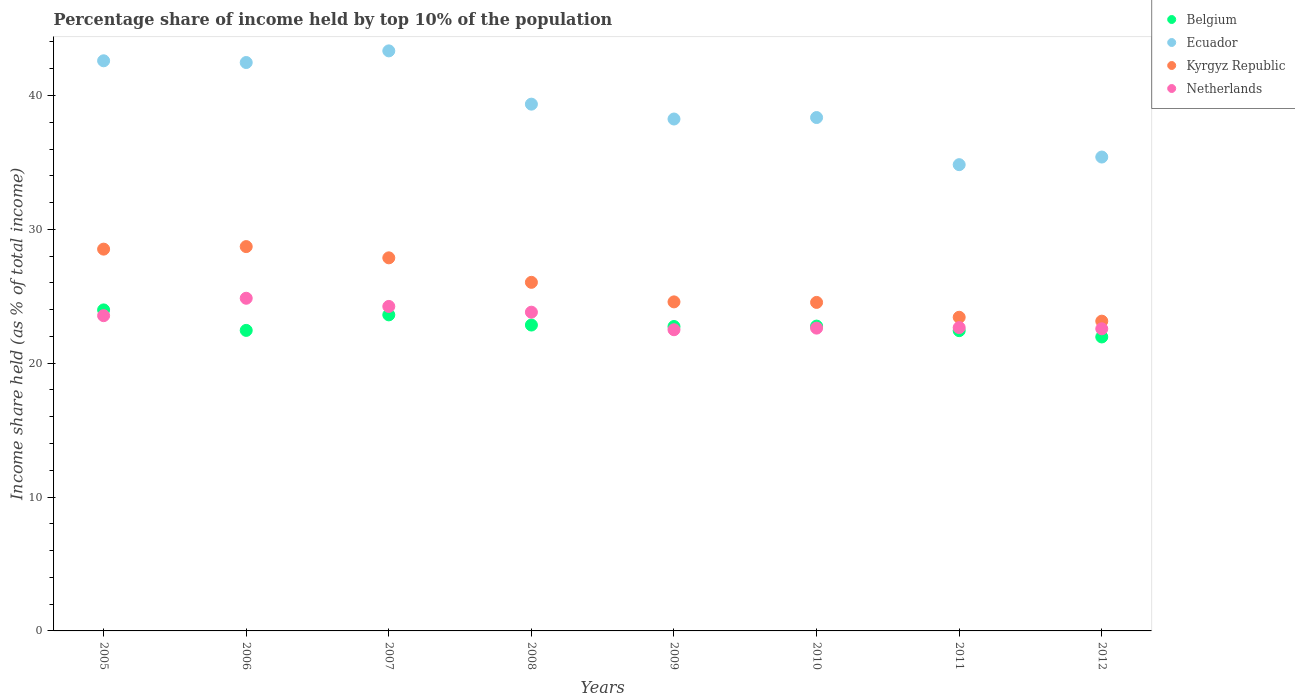Is the number of dotlines equal to the number of legend labels?
Your response must be concise. Yes. What is the percentage share of income held by top 10% of the population in Netherlands in 2006?
Provide a succinct answer. 24.85. Across all years, what is the maximum percentage share of income held by top 10% of the population in Netherlands?
Offer a terse response. 24.85. Across all years, what is the minimum percentage share of income held by top 10% of the population in Ecuador?
Offer a very short reply. 34.83. In which year was the percentage share of income held by top 10% of the population in Ecuador maximum?
Your answer should be very brief. 2007. What is the total percentage share of income held by top 10% of the population in Kyrgyz Republic in the graph?
Provide a short and direct response. 206.83. What is the difference between the percentage share of income held by top 10% of the population in Belgium in 2005 and that in 2008?
Provide a short and direct response. 1.13. What is the difference between the percentage share of income held by top 10% of the population in Belgium in 2005 and the percentage share of income held by top 10% of the population in Kyrgyz Republic in 2009?
Make the answer very short. -0.6. What is the average percentage share of income held by top 10% of the population in Kyrgyz Republic per year?
Offer a very short reply. 25.85. In the year 2009, what is the difference between the percentage share of income held by top 10% of the population in Belgium and percentage share of income held by top 10% of the population in Ecuador?
Offer a very short reply. -15.5. In how many years, is the percentage share of income held by top 10% of the population in Belgium greater than 28 %?
Your answer should be very brief. 0. What is the ratio of the percentage share of income held by top 10% of the population in Ecuador in 2008 to that in 2009?
Your answer should be compact. 1.03. Is the difference between the percentage share of income held by top 10% of the population in Belgium in 2011 and 2012 greater than the difference between the percentage share of income held by top 10% of the population in Ecuador in 2011 and 2012?
Provide a short and direct response. Yes. What is the difference between the highest and the second highest percentage share of income held by top 10% of the population in Netherlands?
Provide a succinct answer. 0.61. What is the difference between the highest and the lowest percentage share of income held by top 10% of the population in Kyrgyz Republic?
Offer a terse response. 5.57. Is it the case that in every year, the sum of the percentage share of income held by top 10% of the population in Netherlands and percentage share of income held by top 10% of the population in Kyrgyz Republic  is greater than the percentage share of income held by top 10% of the population in Belgium?
Your answer should be compact. Yes. Does the percentage share of income held by top 10% of the population in Netherlands monotonically increase over the years?
Your answer should be compact. No. How many dotlines are there?
Keep it short and to the point. 4. Are the values on the major ticks of Y-axis written in scientific E-notation?
Keep it short and to the point. No. How many legend labels are there?
Provide a short and direct response. 4. How are the legend labels stacked?
Your answer should be compact. Vertical. What is the title of the graph?
Offer a very short reply. Percentage share of income held by top 10% of the population. What is the label or title of the X-axis?
Your answer should be very brief. Years. What is the label or title of the Y-axis?
Provide a succinct answer. Income share held (as % of total income). What is the Income share held (as % of total income) in Belgium in 2005?
Ensure brevity in your answer.  23.98. What is the Income share held (as % of total income) of Ecuador in 2005?
Offer a very short reply. 42.59. What is the Income share held (as % of total income) in Kyrgyz Republic in 2005?
Make the answer very short. 28.52. What is the Income share held (as % of total income) in Netherlands in 2005?
Ensure brevity in your answer.  23.55. What is the Income share held (as % of total income) in Belgium in 2006?
Offer a terse response. 22.45. What is the Income share held (as % of total income) in Ecuador in 2006?
Offer a terse response. 42.46. What is the Income share held (as % of total income) of Kyrgyz Republic in 2006?
Make the answer very short. 28.71. What is the Income share held (as % of total income) of Netherlands in 2006?
Keep it short and to the point. 24.85. What is the Income share held (as % of total income) of Belgium in 2007?
Your response must be concise. 23.61. What is the Income share held (as % of total income) of Ecuador in 2007?
Ensure brevity in your answer.  43.33. What is the Income share held (as % of total income) of Kyrgyz Republic in 2007?
Your answer should be very brief. 27.87. What is the Income share held (as % of total income) in Netherlands in 2007?
Ensure brevity in your answer.  24.24. What is the Income share held (as % of total income) in Belgium in 2008?
Make the answer very short. 22.85. What is the Income share held (as % of total income) in Ecuador in 2008?
Provide a short and direct response. 39.35. What is the Income share held (as % of total income) of Kyrgyz Republic in 2008?
Give a very brief answer. 26.04. What is the Income share held (as % of total income) in Netherlands in 2008?
Your answer should be very brief. 23.81. What is the Income share held (as % of total income) of Belgium in 2009?
Your answer should be very brief. 22.74. What is the Income share held (as % of total income) in Ecuador in 2009?
Make the answer very short. 38.24. What is the Income share held (as % of total income) in Kyrgyz Republic in 2009?
Offer a very short reply. 24.58. What is the Income share held (as % of total income) of Netherlands in 2009?
Keep it short and to the point. 22.5. What is the Income share held (as % of total income) in Belgium in 2010?
Make the answer very short. 22.77. What is the Income share held (as % of total income) in Ecuador in 2010?
Offer a terse response. 38.35. What is the Income share held (as % of total income) in Kyrgyz Republic in 2010?
Offer a terse response. 24.54. What is the Income share held (as % of total income) of Netherlands in 2010?
Keep it short and to the point. 22.62. What is the Income share held (as % of total income) of Belgium in 2011?
Your response must be concise. 22.43. What is the Income share held (as % of total income) in Ecuador in 2011?
Provide a succinct answer. 34.83. What is the Income share held (as % of total income) in Kyrgyz Republic in 2011?
Give a very brief answer. 23.43. What is the Income share held (as % of total income) of Netherlands in 2011?
Make the answer very short. 22.66. What is the Income share held (as % of total income) of Belgium in 2012?
Provide a short and direct response. 21.96. What is the Income share held (as % of total income) of Ecuador in 2012?
Offer a very short reply. 35.4. What is the Income share held (as % of total income) of Kyrgyz Republic in 2012?
Provide a short and direct response. 23.14. What is the Income share held (as % of total income) in Netherlands in 2012?
Provide a succinct answer. 22.57. Across all years, what is the maximum Income share held (as % of total income) in Belgium?
Offer a terse response. 23.98. Across all years, what is the maximum Income share held (as % of total income) of Ecuador?
Your answer should be very brief. 43.33. Across all years, what is the maximum Income share held (as % of total income) of Kyrgyz Republic?
Give a very brief answer. 28.71. Across all years, what is the maximum Income share held (as % of total income) of Netherlands?
Offer a terse response. 24.85. Across all years, what is the minimum Income share held (as % of total income) of Belgium?
Your answer should be compact. 21.96. Across all years, what is the minimum Income share held (as % of total income) in Ecuador?
Give a very brief answer. 34.83. Across all years, what is the minimum Income share held (as % of total income) in Kyrgyz Republic?
Give a very brief answer. 23.14. Across all years, what is the minimum Income share held (as % of total income) of Netherlands?
Offer a terse response. 22.5. What is the total Income share held (as % of total income) in Belgium in the graph?
Give a very brief answer. 182.79. What is the total Income share held (as % of total income) in Ecuador in the graph?
Provide a succinct answer. 314.55. What is the total Income share held (as % of total income) of Kyrgyz Republic in the graph?
Your answer should be very brief. 206.83. What is the total Income share held (as % of total income) of Netherlands in the graph?
Provide a succinct answer. 186.8. What is the difference between the Income share held (as % of total income) of Belgium in 2005 and that in 2006?
Give a very brief answer. 1.53. What is the difference between the Income share held (as % of total income) of Ecuador in 2005 and that in 2006?
Keep it short and to the point. 0.13. What is the difference between the Income share held (as % of total income) of Kyrgyz Republic in 2005 and that in 2006?
Ensure brevity in your answer.  -0.19. What is the difference between the Income share held (as % of total income) of Netherlands in 2005 and that in 2006?
Provide a short and direct response. -1.3. What is the difference between the Income share held (as % of total income) in Belgium in 2005 and that in 2007?
Provide a short and direct response. 0.37. What is the difference between the Income share held (as % of total income) in Ecuador in 2005 and that in 2007?
Provide a succinct answer. -0.74. What is the difference between the Income share held (as % of total income) of Kyrgyz Republic in 2005 and that in 2007?
Keep it short and to the point. 0.65. What is the difference between the Income share held (as % of total income) of Netherlands in 2005 and that in 2007?
Offer a very short reply. -0.69. What is the difference between the Income share held (as % of total income) of Belgium in 2005 and that in 2008?
Provide a succinct answer. 1.13. What is the difference between the Income share held (as % of total income) in Ecuador in 2005 and that in 2008?
Offer a very short reply. 3.24. What is the difference between the Income share held (as % of total income) in Kyrgyz Republic in 2005 and that in 2008?
Provide a short and direct response. 2.48. What is the difference between the Income share held (as % of total income) of Netherlands in 2005 and that in 2008?
Provide a succinct answer. -0.26. What is the difference between the Income share held (as % of total income) in Belgium in 2005 and that in 2009?
Your answer should be very brief. 1.24. What is the difference between the Income share held (as % of total income) in Ecuador in 2005 and that in 2009?
Provide a short and direct response. 4.35. What is the difference between the Income share held (as % of total income) in Kyrgyz Republic in 2005 and that in 2009?
Your answer should be compact. 3.94. What is the difference between the Income share held (as % of total income) of Belgium in 2005 and that in 2010?
Offer a very short reply. 1.21. What is the difference between the Income share held (as % of total income) in Ecuador in 2005 and that in 2010?
Provide a short and direct response. 4.24. What is the difference between the Income share held (as % of total income) of Kyrgyz Republic in 2005 and that in 2010?
Your answer should be very brief. 3.98. What is the difference between the Income share held (as % of total income) in Netherlands in 2005 and that in 2010?
Offer a terse response. 0.93. What is the difference between the Income share held (as % of total income) of Belgium in 2005 and that in 2011?
Offer a very short reply. 1.55. What is the difference between the Income share held (as % of total income) in Ecuador in 2005 and that in 2011?
Keep it short and to the point. 7.76. What is the difference between the Income share held (as % of total income) in Kyrgyz Republic in 2005 and that in 2011?
Your response must be concise. 5.09. What is the difference between the Income share held (as % of total income) of Netherlands in 2005 and that in 2011?
Give a very brief answer. 0.89. What is the difference between the Income share held (as % of total income) of Belgium in 2005 and that in 2012?
Make the answer very short. 2.02. What is the difference between the Income share held (as % of total income) in Ecuador in 2005 and that in 2012?
Your answer should be compact. 7.19. What is the difference between the Income share held (as % of total income) of Kyrgyz Republic in 2005 and that in 2012?
Provide a succinct answer. 5.38. What is the difference between the Income share held (as % of total income) of Belgium in 2006 and that in 2007?
Offer a terse response. -1.16. What is the difference between the Income share held (as % of total income) of Ecuador in 2006 and that in 2007?
Make the answer very short. -0.87. What is the difference between the Income share held (as % of total income) of Kyrgyz Republic in 2006 and that in 2007?
Give a very brief answer. 0.84. What is the difference between the Income share held (as % of total income) in Netherlands in 2006 and that in 2007?
Keep it short and to the point. 0.61. What is the difference between the Income share held (as % of total income) of Belgium in 2006 and that in 2008?
Give a very brief answer. -0.4. What is the difference between the Income share held (as % of total income) in Ecuador in 2006 and that in 2008?
Keep it short and to the point. 3.11. What is the difference between the Income share held (as % of total income) in Kyrgyz Republic in 2006 and that in 2008?
Give a very brief answer. 2.67. What is the difference between the Income share held (as % of total income) in Belgium in 2006 and that in 2009?
Offer a very short reply. -0.29. What is the difference between the Income share held (as % of total income) in Ecuador in 2006 and that in 2009?
Provide a succinct answer. 4.22. What is the difference between the Income share held (as % of total income) of Kyrgyz Republic in 2006 and that in 2009?
Give a very brief answer. 4.13. What is the difference between the Income share held (as % of total income) of Netherlands in 2006 and that in 2009?
Give a very brief answer. 2.35. What is the difference between the Income share held (as % of total income) in Belgium in 2006 and that in 2010?
Ensure brevity in your answer.  -0.32. What is the difference between the Income share held (as % of total income) in Ecuador in 2006 and that in 2010?
Offer a terse response. 4.11. What is the difference between the Income share held (as % of total income) of Kyrgyz Republic in 2006 and that in 2010?
Provide a short and direct response. 4.17. What is the difference between the Income share held (as % of total income) of Netherlands in 2006 and that in 2010?
Provide a short and direct response. 2.23. What is the difference between the Income share held (as % of total income) in Belgium in 2006 and that in 2011?
Your answer should be very brief. 0.02. What is the difference between the Income share held (as % of total income) in Ecuador in 2006 and that in 2011?
Your answer should be compact. 7.63. What is the difference between the Income share held (as % of total income) in Kyrgyz Republic in 2006 and that in 2011?
Offer a very short reply. 5.28. What is the difference between the Income share held (as % of total income) in Netherlands in 2006 and that in 2011?
Give a very brief answer. 2.19. What is the difference between the Income share held (as % of total income) in Belgium in 2006 and that in 2012?
Offer a terse response. 0.49. What is the difference between the Income share held (as % of total income) of Ecuador in 2006 and that in 2012?
Your response must be concise. 7.06. What is the difference between the Income share held (as % of total income) in Kyrgyz Republic in 2006 and that in 2012?
Offer a terse response. 5.57. What is the difference between the Income share held (as % of total income) in Netherlands in 2006 and that in 2012?
Keep it short and to the point. 2.28. What is the difference between the Income share held (as % of total income) in Belgium in 2007 and that in 2008?
Keep it short and to the point. 0.76. What is the difference between the Income share held (as % of total income) of Ecuador in 2007 and that in 2008?
Your answer should be very brief. 3.98. What is the difference between the Income share held (as % of total income) of Kyrgyz Republic in 2007 and that in 2008?
Keep it short and to the point. 1.83. What is the difference between the Income share held (as % of total income) in Netherlands in 2007 and that in 2008?
Offer a very short reply. 0.43. What is the difference between the Income share held (as % of total income) of Belgium in 2007 and that in 2009?
Provide a short and direct response. 0.87. What is the difference between the Income share held (as % of total income) of Ecuador in 2007 and that in 2009?
Offer a terse response. 5.09. What is the difference between the Income share held (as % of total income) of Kyrgyz Republic in 2007 and that in 2009?
Give a very brief answer. 3.29. What is the difference between the Income share held (as % of total income) of Netherlands in 2007 and that in 2009?
Offer a terse response. 1.74. What is the difference between the Income share held (as % of total income) of Belgium in 2007 and that in 2010?
Make the answer very short. 0.84. What is the difference between the Income share held (as % of total income) of Ecuador in 2007 and that in 2010?
Offer a terse response. 4.98. What is the difference between the Income share held (as % of total income) of Kyrgyz Republic in 2007 and that in 2010?
Offer a very short reply. 3.33. What is the difference between the Income share held (as % of total income) in Netherlands in 2007 and that in 2010?
Offer a very short reply. 1.62. What is the difference between the Income share held (as % of total income) of Belgium in 2007 and that in 2011?
Ensure brevity in your answer.  1.18. What is the difference between the Income share held (as % of total income) of Kyrgyz Republic in 2007 and that in 2011?
Your answer should be compact. 4.44. What is the difference between the Income share held (as % of total income) in Netherlands in 2007 and that in 2011?
Keep it short and to the point. 1.58. What is the difference between the Income share held (as % of total income) in Belgium in 2007 and that in 2012?
Your answer should be compact. 1.65. What is the difference between the Income share held (as % of total income) of Ecuador in 2007 and that in 2012?
Offer a terse response. 7.93. What is the difference between the Income share held (as % of total income) in Kyrgyz Republic in 2007 and that in 2012?
Provide a succinct answer. 4.73. What is the difference between the Income share held (as % of total income) of Netherlands in 2007 and that in 2012?
Your answer should be compact. 1.67. What is the difference between the Income share held (as % of total income) in Belgium in 2008 and that in 2009?
Make the answer very short. 0.11. What is the difference between the Income share held (as % of total income) of Ecuador in 2008 and that in 2009?
Offer a terse response. 1.11. What is the difference between the Income share held (as % of total income) of Kyrgyz Republic in 2008 and that in 2009?
Keep it short and to the point. 1.46. What is the difference between the Income share held (as % of total income) in Netherlands in 2008 and that in 2009?
Ensure brevity in your answer.  1.31. What is the difference between the Income share held (as % of total income) of Belgium in 2008 and that in 2010?
Your response must be concise. 0.08. What is the difference between the Income share held (as % of total income) in Kyrgyz Republic in 2008 and that in 2010?
Offer a very short reply. 1.5. What is the difference between the Income share held (as % of total income) in Netherlands in 2008 and that in 2010?
Offer a very short reply. 1.19. What is the difference between the Income share held (as % of total income) in Belgium in 2008 and that in 2011?
Provide a short and direct response. 0.42. What is the difference between the Income share held (as % of total income) in Ecuador in 2008 and that in 2011?
Your answer should be very brief. 4.52. What is the difference between the Income share held (as % of total income) in Kyrgyz Republic in 2008 and that in 2011?
Offer a very short reply. 2.61. What is the difference between the Income share held (as % of total income) in Netherlands in 2008 and that in 2011?
Provide a short and direct response. 1.15. What is the difference between the Income share held (as % of total income) in Belgium in 2008 and that in 2012?
Your answer should be very brief. 0.89. What is the difference between the Income share held (as % of total income) of Ecuador in 2008 and that in 2012?
Offer a terse response. 3.95. What is the difference between the Income share held (as % of total income) in Netherlands in 2008 and that in 2012?
Provide a short and direct response. 1.24. What is the difference between the Income share held (as % of total income) of Belgium in 2009 and that in 2010?
Your response must be concise. -0.03. What is the difference between the Income share held (as % of total income) in Ecuador in 2009 and that in 2010?
Your answer should be very brief. -0.11. What is the difference between the Income share held (as % of total income) in Kyrgyz Republic in 2009 and that in 2010?
Offer a terse response. 0.04. What is the difference between the Income share held (as % of total income) in Netherlands in 2009 and that in 2010?
Offer a very short reply. -0.12. What is the difference between the Income share held (as % of total income) in Belgium in 2009 and that in 2011?
Your answer should be compact. 0.31. What is the difference between the Income share held (as % of total income) of Ecuador in 2009 and that in 2011?
Keep it short and to the point. 3.41. What is the difference between the Income share held (as % of total income) in Kyrgyz Republic in 2009 and that in 2011?
Keep it short and to the point. 1.15. What is the difference between the Income share held (as % of total income) of Netherlands in 2009 and that in 2011?
Offer a very short reply. -0.16. What is the difference between the Income share held (as % of total income) in Belgium in 2009 and that in 2012?
Provide a succinct answer. 0.78. What is the difference between the Income share held (as % of total income) in Ecuador in 2009 and that in 2012?
Keep it short and to the point. 2.84. What is the difference between the Income share held (as % of total income) of Kyrgyz Republic in 2009 and that in 2012?
Give a very brief answer. 1.44. What is the difference between the Income share held (as % of total income) in Netherlands in 2009 and that in 2012?
Offer a very short reply. -0.07. What is the difference between the Income share held (as % of total income) of Belgium in 2010 and that in 2011?
Provide a short and direct response. 0.34. What is the difference between the Income share held (as % of total income) of Ecuador in 2010 and that in 2011?
Provide a short and direct response. 3.52. What is the difference between the Income share held (as % of total income) of Kyrgyz Republic in 2010 and that in 2011?
Keep it short and to the point. 1.11. What is the difference between the Income share held (as % of total income) in Netherlands in 2010 and that in 2011?
Provide a short and direct response. -0.04. What is the difference between the Income share held (as % of total income) of Belgium in 2010 and that in 2012?
Offer a very short reply. 0.81. What is the difference between the Income share held (as % of total income) in Ecuador in 2010 and that in 2012?
Give a very brief answer. 2.95. What is the difference between the Income share held (as % of total income) in Kyrgyz Republic in 2010 and that in 2012?
Keep it short and to the point. 1.4. What is the difference between the Income share held (as % of total income) in Belgium in 2011 and that in 2012?
Ensure brevity in your answer.  0.47. What is the difference between the Income share held (as % of total income) in Ecuador in 2011 and that in 2012?
Make the answer very short. -0.57. What is the difference between the Income share held (as % of total income) of Kyrgyz Republic in 2011 and that in 2012?
Offer a very short reply. 0.29. What is the difference between the Income share held (as % of total income) of Netherlands in 2011 and that in 2012?
Ensure brevity in your answer.  0.09. What is the difference between the Income share held (as % of total income) in Belgium in 2005 and the Income share held (as % of total income) in Ecuador in 2006?
Ensure brevity in your answer.  -18.48. What is the difference between the Income share held (as % of total income) in Belgium in 2005 and the Income share held (as % of total income) in Kyrgyz Republic in 2006?
Provide a succinct answer. -4.73. What is the difference between the Income share held (as % of total income) of Belgium in 2005 and the Income share held (as % of total income) of Netherlands in 2006?
Provide a short and direct response. -0.87. What is the difference between the Income share held (as % of total income) of Ecuador in 2005 and the Income share held (as % of total income) of Kyrgyz Republic in 2006?
Offer a terse response. 13.88. What is the difference between the Income share held (as % of total income) of Ecuador in 2005 and the Income share held (as % of total income) of Netherlands in 2006?
Make the answer very short. 17.74. What is the difference between the Income share held (as % of total income) of Kyrgyz Republic in 2005 and the Income share held (as % of total income) of Netherlands in 2006?
Ensure brevity in your answer.  3.67. What is the difference between the Income share held (as % of total income) of Belgium in 2005 and the Income share held (as % of total income) of Ecuador in 2007?
Give a very brief answer. -19.35. What is the difference between the Income share held (as % of total income) in Belgium in 2005 and the Income share held (as % of total income) in Kyrgyz Republic in 2007?
Your answer should be compact. -3.89. What is the difference between the Income share held (as % of total income) in Belgium in 2005 and the Income share held (as % of total income) in Netherlands in 2007?
Make the answer very short. -0.26. What is the difference between the Income share held (as % of total income) of Ecuador in 2005 and the Income share held (as % of total income) of Kyrgyz Republic in 2007?
Provide a succinct answer. 14.72. What is the difference between the Income share held (as % of total income) in Ecuador in 2005 and the Income share held (as % of total income) in Netherlands in 2007?
Make the answer very short. 18.35. What is the difference between the Income share held (as % of total income) of Kyrgyz Republic in 2005 and the Income share held (as % of total income) of Netherlands in 2007?
Your answer should be compact. 4.28. What is the difference between the Income share held (as % of total income) of Belgium in 2005 and the Income share held (as % of total income) of Ecuador in 2008?
Offer a terse response. -15.37. What is the difference between the Income share held (as % of total income) in Belgium in 2005 and the Income share held (as % of total income) in Kyrgyz Republic in 2008?
Provide a short and direct response. -2.06. What is the difference between the Income share held (as % of total income) in Belgium in 2005 and the Income share held (as % of total income) in Netherlands in 2008?
Ensure brevity in your answer.  0.17. What is the difference between the Income share held (as % of total income) in Ecuador in 2005 and the Income share held (as % of total income) in Kyrgyz Republic in 2008?
Give a very brief answer. 16.55. What is the difference between the Income share held (as % of total income) of Ecuador in 2005 and the Income share held (as % of total income) of Netherlands in 2008?
Keep it short and to the point. 18.78. What is the difference between the Income share held (as % of total income) in Kyrgyz Republic in 2005 and the Income share held (as % of total income) in Netherlands in 2008?
Your answer should be compact. 4.71. What is the difference between the Income share held (as % of total income) of Belgium in 2005 and the Income share held (as % of total income) of Ecuador in 2009?
Provide a short and direct response. -14.26. What is the difference between the Income share held (as % of total income) in Belgium in 2005 and the Income share held (as % of total income) in Kyrgyz Republic in 2009?
Keep it short and to the point. -0.6. What is the difference between the Income share held (as % of total income) of Belgium in 2005 and the Income share held (as % of total income) of Netherlands in 2009?
Your response must be concise. 1.48. What is the difference between the Income share held (as % of total income) of Ecuador in 2005 and the Income share held (as % of total income) of Kyrgyz Republic in 2009?
Your response must be concise. 18.01. What is the difference between the Income share held (as % of total income) in Ecuador in 2005 and the Income share held (as % of total income) in Netherlands in 2009?
Give a very brief answer. 20.09. What is the difference between the Income share held (as % of total income) of Kyrgyz Republic in 2005 and the Income share held (as % of total income) of Netherlands in 2009?
Provide a short and direct response. 6.02. What is the difference between the Income share held (as % of total income) of Belgium in 2005 and the Income share held (as % of total income) of Ecuador in 2010?
Your answer should be compact. -14.37. What is the difference between the Income share held (as % of total income) of Belgium in 2005 and the Income share held (as % of total income) of Kyrgyz Republic in 2010?
Your answer should be compact. -0.56. What is the difference between the Income share held (as % of total income) in Belgium in 2005 and the Income share held (as % of total income) in Netherlands in 2010?
Your answer should be very brief. 1.36. What is the difference between the Income share held (as % of total income) of Ecuador in 2005 and the Income share held (as % of total income) of Kyrgyz Republic in 2010?
Your answer should be very brief. 18.05. What is the difference between the Income share held (as % of total income) in Ecuador in 2005 and the Income share held (as % of total income) in Netherlands in 2010?
Give a very brief answer. 19.97. What is the difference between the Income share held (as % of total income) of Belgium in 2005 and the Income share held (as % of total income) of Ecuador in 2011?
Make the answer very short. -10.85. What is the difference between the Income share held (as % of total income) in Belgium in 2005 and the Income share held (as % of total income) in Kyrgyz Republic in 2011?
Keep it short and to the point. 0.55. What is the difference between the Income share held (as % of total income) in Belgium in 2005 and the Income share held (as % of total income) in Netherlands in 2011?
Give a very brief answer. 1.32. What is the difference between the Income share held (as % of total income) in Ecuador in 2005 and the Income share held (as % of total income) in Kyrgyz Republic in 2011?
Provide a short and direct response. 19.16. What is the difference between the Income share held (as % of total income) in Ecuador in 2005 and the Income share held (as % of total income) in Netherlands in 2011?
Make the answer very short. 19.93. What is the difference between the Income share held (as % of total income) of Kyrgyz Republic in 2005 and the Income share held (as % of total income) of Netherlands in 2011?
Provide a short and direct response. 5.86. What is the difference between the Income share held (as % of total income) in Belgium in 2005 and the Income share held (as % of total income) in Ecuador in 2012?
Provide a short and direct response. -11.42. What is the difference between the Income share held (as % of total income) of Belgium in 2005 and the Income share held (as % of total income) of Kyrgyz Republic in 2012?
Offer a terse response. 0.84. What is the difference between the Income share held (as % of total income) of Belgium in 2005 and the Income share held (as % of total income) of Netherlands in 2012?
Keep it short and to the point. 1.41. What is the difference between the Income share held (as % of total income) in Ecuador in 2005 and the Income share held (as % of total income) in Kyrgyz Republic in 2012?
Provide a short and direct response. 19.45. What is the difference between the Income share held (as % of total income) of Ecuador in 2005 and the Income share held (as % of total income) of Netherlands in 2012?
Provide a succinct answer. 20.02. What is the difference between the Income share held (as % of total income) in Kyrgyz Republic in 2005 and the Income share held (as % of total income) in Netherlands in 2012?
Your response must be concise. 5.95. What is the difference between the Income share held (as % of total income) in Belgium in 2006 and the Income share held (as % of total income) in Ecuador in 2007?
Make the answer very short. -20.88. What is the difference between the Income share held (as % of total income) of Belgium in 2006 and the Income share held (as % of total income) of Kyrgyz Republic in 2007?
Provide a short and direct response. -5.42. What is the difference between the Income share held (as % of total income) of Belgium in 2006 and the Income share held (as % of total income) of Netherlands in 2007?
Your response must be concise. -1.79. What is the difference between the Income share held (as % of total income) of Ecuador in 2006 and the Income share held (as % of total income) of Kyrgyz Republic in 2007?
Keep it short and to the point. 14.59. What is the difference between the Income share held (as % of total income) of Ecuador in 2006 and the Income share held (as % of total income) of Netherlands in 2007?
Ensure brevity in your answer.  18.22. What is the difference between the Income share held (as % of total income) in Kyrgyz Republic in 2006 and the Income share held (as % of total income) in Netherlands in 2007?
Offer a very short reply. 4.47. What is the difference between the Income share held (as % of total income) in Belgium in 2006 and the Income share held (as % of total income) in Ecuador in 2008?
Ensure brevity in your answer.  -16.9. What is the difference between the Income share held (as % of total income) of Belgium in 2006 and the Income share held (as % of total income) of Kyrgyz Republic in 2008?
Offer a terse response. -3.59. What is the difference between the Income share held (as % of total income) of Belgium in 2006 and the Income share held (as % of total income) of Netherlands in 2008?
Make the answer very short. -1.36. What is the difference between the Income share held (as % of total income) of Ecuador in 2006 and the Income share held (as % of total income) of Kyrgyz Republic in 2008?
Ensure brevity in your answer.  16.42. What is the difference between the Income share held (as % of total income) in Ecuador in 2006 and the Income share held (as % of total income) in Netherlands in 2008?
Provide a succinct answer. 18.65. What is the difference between the Income share held (as % of total income) in Belgium in 2006 and the Income share held (as % of total income) in Ecuador in 2009?
Your response must be concise. -15.79. What is the difference between the Income share held (as % of total income) in Belgium in 2006 and the Income share held (as % of total income) in Kyrgyz Republic in 2009?
Provide a short and direct response. -2.13. What is the difference between the Income share held (as % of total income) of Ecuador in 2006 and the Income share held (as % of total income) of Kyrgyz Republic in 2009?
Provide a short and direct response. 17.88. What is the difference between the Income share held (as % of total income) in Ecuador in 2006 and the Income share held (as % of total income) in Netherlands in 2009?
Offer a terse response. 19.96. What is the difference between the Income share held (as % of total income) of Kyrgyz Republic in 2006 and the Income share held (as % of total income) of Netherlands in 2009?
Your answer should be compact. 6.21. What is the difference between the Income share held (as % of total income) in Belgium in 2006 and the Income share held (as % of total income) in Ecuador in 2010?
Your answer should be very brief. -15.9. What is the difference between the Income share held (as % of total income) of Belgium in 2006 and the Income share held (as % of total income) of Kyrgyz Republic in 2010?
Ensure brevity in your answer.  -2.09. What is the difference between the Income share held (as % of total income) of Belgium in 2006 and the Income share held (as % of total income) of Netherlands in 2010?
Provide a short and direct response. -0.17. What is the difference between the Income share held (as % of total income) of Ecuador in 2006 and the Income share held (as % of total income) of Kyrgyz Republic in 2010?
Offer a very short reply. 17.92. What is the difference between the Income share held (as % of total income) in Ecuador in 2006 and the Income share held (as % of total income) in Netherlands in 2010?
Offer a very short reply. 19.84. What is the difference between the Income share held (as % of total income) of Kyrgyz Republic in 2006 and the Income share held (as % of total income) of Netherlands in 2010?
Your answer should be compact. 6.09. What is the difference between the Income share held (as % of total income) in Belgium in 2006 and the Income share held (as % of total income) in Ecuador in 2011?
Ensure brevity in your answer.  -12.38. What is the difference between the Income share held (as % of total income) in Belgium in 2006 and the Income share held (as % of total income) in Kyrgyz Republic in 2011?
Your answer should be very brief. -0.98. What is the difference between the Income share held (as % of total income) in Belgium in 2006 and the Income share held (as % of total income) in Netherlands in 2011?
Offer a very short reply. -0.21. What is the difference between the Income share held (as % of total income) of Ecuador in 2006 and the Income share held (as % of total income) of Kyrgyz Republic in 2011?
Make the answer very short. 19.03. What is the difference between the Income share held (as % of total income) in Ecuador in 2006 and the Income share held (as % of total income) in Netherlands in 2011?
Offer a very short reply. 19.8. What is the difference between the Income share held (as % of total income) in Kyrgyz Republic in 2006 and the Income share held (as % of total income) in Netherlands in 2011?
Your answer should be very brief. 6.05. What is the difference between the Income share held (as % of total income) in Belgium in 2006 and the Income share held (as % of total income) in Ecuador in 2012?
Keep it short and to the point. -12.95. What is the difference between the Income share held (as % of total income) in Belgium in 2006 and the Income share held (as % of total income) in Kyrgyz Republic in 2012?
Provide a succinct answer. -0.69. What is the difference between the Income share held (as % of total income) in Belgium in 2006 and the Income share held (as % of total income) in Netherlands in 2012?
Keep it short and to the point. -0.12. What is the difference between the Income share held (as % of total income) of Ecuador in 2006 and the Income share held (as % of total income) of Kyrgyz Republic in 2012?
Give a very brief answer. 19.32. What is the difference between the Income share held (as % of total income) of Ecuador in 2006 and the Income share held (as % of total income) of Netherlands in 2012?
Provide a succinct answer. 19.89. What is the difference between the Income share held (as % of total income) in Kyrgyz Republic in 2006 and the Income share held (as % of total income) in Netherlands in 2012?
Ensure brevity in your answer.  6.14. What is the difference between the Income share held (as % of total income) in Belgium in 2007 and the Income share held (as % of total income) in Ecuador in 2008?
Provide a succinct answer. -15.74. What is the difference between the Income share held (as % of total income) of Belgium in 2007 and the Income share held (as % of total income) of Kyrgyz Republic in 2008?
Ensure brevity in your answer.  -2.43. What is the difference between the Income share held (as % of total income) of Ecuador in 2007 and the Income share held (as % of total income) of Kyrgyz Republic in 2008?
Your answer should be very brief. 17.29. What is the difference between the Income share held (as % of total income) of Ecuador in 2007 and the Income share held (as % of total income) of Netherlands in 2008?
Provide a short and direct response. 19.52. What is the difference between the Income share held (as % of total income) of Kyrgyz Republic in 2007 and the Income share held (as % of total income) of Netherlands in 2008?
Offer a terse response. 4.06. What is the difference between the Income share held (as % of total income) of Belgium in 2007 and the Income share held (as % of total income) of Ecuador in 2009?
Your response must be concise. -14.63. What is the difference between the Income share held (as % of total income) in Belgium in 2007 and the Income share held (as % of total income) in Kyrgyz Republic in 2009?
Offer a terse response. -0.97. What is the difference between the Income share held (as % of total income) in Belgium in 2007 and the Income share held (as % of total income) in Netherlands in 2009?
Offer a terse response. 1.11. What is the difference between the Income share held (as % of total income) in Ecuador in 2007 and the Income share held (as % of total income) in Kyrgyz Republic in 2009?
Offer a terse response. 18.75. What is the difference between the Income share held (as % of total income) of Ecuador in 2007 and the Income share held (as % of total income) of Netherlands in 2009?
Offer a terse response. 20.83. What is the difference between the Income share held (as % of total income) in Kyrgyz Republic in 2007 and the Income share held (as % of total income) in Netherlands in 2009?
Offer a very short reply. 5.37. What is the difference between the Income share held (as % of total income) in Belgium in 2007 and the Income share held (as % of total income) in Ecuador in 2010?
Keep it short and to the point. -14.74. What is the difference between the Income share held (as % of total income) of Belgium in 2007 and the Income share held (as % of total income) of Kyrgyz Republic in 2010?
Provide a succinct answer. -0.93. What is the difference between the Income share held (as % of total income) in Belgium in 2007 and the Income share held (as % of total income) in Netherlands in 2010?
Offer a very short reply. 0.99. What is the difference between the Income share held (as % of total income) of Ecuador in 2007 and the Income share held (as % of total income) of Kyrgyz Republic in 2010?
Ensure brevity in your answer.  18.79. What is the difference between the Income share held (as % of total income) of Ecuador in 2007 and the Income share held (as % of total income) of Netherlands in 2010?
Offer a very short reply. 20.71. What is the difference between the Income share held (as % of total income) of Kyrgyz Republic in 2007 and the Income share held (as % of total income) of Netherlands in 2010?
Offer a very short reply. 5.25. What is the difference between the Income share held (as % of total income) in Belgium in 2007 and the Income share held (as % of total income) in Ecuador in 2011?
Make the answer very short. -11.22. What is the difference between the Income share held (as % of total income) of Belgium in 2007 and the Income share held (as % of total income) of Kyrgyz Republic in 2011?
Provide a succinct answer. 0.18. What is the difference between the Income share held (as % of total income) in Ecuador in 2007 and the Income share held (as % of total income) in Kyrgyz Republic in 2011?
Your answer should be compact. 19.9. What is the difference between the Income share held (as % of total income) of Ecuador in 2007 and the Income share held (as % of total income) of Netherlands in 2011?
Keep it short and to the point. 20.67. What is the difference between the Income share held (as % of total income) of Kyrgyz Republic in 2007 and the Income share held (as % of total income) of Netherlands in 2011?
Your answer should be very brief. 5.21. What is the difference between the Income share held (as % of total income) of Belgium in 2007 and the Income share held (as % of total income) of Ecuador in 2012?
Give a very brief answer. -11.79. What is the difference between the Income share held (as % of total income) in Belgium in 2007 and the Income share held (as % of total income) in Kyrgyz Republic in 2012?
Keep it short and to the point. 0.47. What is the difference between the Income share held (as % of total income) in Belgium in 2007 and the Income share held (as % of total income) in Netherlands in 2012?
Your response must be concise. 1.04. What is the difference between the Income share held (as % of total income) in Ecuador in 2007 and the Income share held (as % of total income) in Kyrgyz Republic in 2012?
Your answer should be compact. 20.19. What is the difference between the Income share held (as % of total income) in Ecuador in 2007 and the Income share held (as % of total income) in Netherlands in 2012?
Offer a terse response. 20.76. What is the difference between the Income share held (as % of total income) of Kyrgyz Republic in 2007 and the Income share held (as % of total income) of Netherlands in 2012?
Your answer should be very brief. 5.3. What is the difference between the Income share held (as % of total income) of Belgium in 2008 and the Income share held (as % of total income) of Ecuador in 2009?
Your answer should be compact. -15.39. What is the difference between the Income share held (as % of total income) in Belgium in 2008 and the Income share held (as % of total income) in Kyrgyz Republic in 2009?
Offer a terse response. -1.73. What is the difference between the Income share held (as % of total income) in Belgium in 2008 and the Income share held (as % of total income) in Netherlands in 2009?
Provide a short and direct response. 0.35. What is the difference between the Income share held (as % of total income) of Ecuador in 2008 and the Income share held (as % of total income) of Kyrgyz Republic in 2009?
Your answer should be compact. 14.77. What is the difference between the Income share held (as % of total income) in Ecuador in 2008 and the Income share held (as % of total income) in Netherlands in 2009?
Your answer should be compact. 16.85. What is the difference between the Income share held (as % of total income) of Kyrgyz Republic in 2008 and the Income share held (as % of total income) of Netherlands in 2009?
Offer a terse response. 3.54. What is the difference between the Income share held (as % of total income) in Belgium in 2008 and the Income share held (as % of total income) in Ecuador in 2010?
Offer a very short reply. -15.5. What is the difference between the Income share held (as % of total income) of Belgium in 2008 and the Income share held (as % of total income) of Kyrgyz Republic in 2010?
Your answer should be compact. -1.69. What is the difference between the Income share held (as % of total income) of Belgium in 2008 and the Income share held (as % of total income) of Netherlands in 2010?
Make the answer very short. 0.23. What is the difference between the Income share held (as % of total income) in Ecuador in 2008 and the Income share held (as % of total income) in Kyrgyz Republic in 2010?
Offer a very short reply. 14.81. What is the difference between the Income share held (as % of total income) in Ecuador in 2008 and the Income share held (as % of total income) in Netherlands in 2010?
Your answer should be compact. 16.73. What is the difference between the Income share held (as % of total income) of Kyrgyz Republic in 2008 and the Income share held (as % of total income) of Netherlands in 2010?
Keep it short and to the point. 3.42. What is the difference between the Income share held (as % of total income) in Belgium in 2008 and the Income share held (as % of total income) in Ecuador in 2011?
Make the answer very short. -11.98. What is the difference between the Income share held (as % of total income) in Belgium in 2008 and the Income share held (as % of total income) in Kyrgyz Republic in 2011?
Your response must be concise. -0.58. What is the difference between the Income share held (as % of total income) of Belgium in 2008 and the Income share held (as % of total income) of Netherlands in 2011?
Keep it short and to the point. 0.19. What is the difference between the Income share held (as % of total income) of Ecuador in 2008 and the Income share held (as % of total income) of Kyrgyz Republic in 2011?
Provide a succinct answer. 15.92. What is the difference between the Income share held (as % of total income) of Ecuador in 2008 and the Income share held (as % of total income) of Netherlands in 2011?
Your answer should be very brief. 16.69. What is the difference between the Income share held (as % of total income) in Kyrgyz Republic in 2008 and the Income share held (as % of total income) in Netherlands in 2011?
Provide a succinct answer. 3.38. What is the difference between the Income share held (as % of total income) of Belgium in 2008 and the Income share held (as % of total income) of Ecuador in 2012?
Make the answer very short. -12.55. What is the difference between the Income share held (as % of total income) of Belgium in 2008 and the Income share held (as % of total income) of Kyrgyz Republic in 2012?
Keep it short and to the point. -0.29. What is the difference between the Income share held (as % of total income) in Belgium in 2008 and the Income share held (as % of total income) in Netherlands in 2012?
Provide a short and direct response. 0.28. What is the difference between the Income share held (as % of total income) in Ecuador in 2008 and the Income share held (as % of total income) in Kyrgyz Republic in 2012?
Offer a terse response. 16.21. What is the difference between the Income share held (as % of total income) in Ecuador in 2008 and the Income share held (as % of total income) in Netherlands in 2012?
Provide a short and direct response. 16.78. What is the difference between the Income share held (as % of total income) in Kyrgyz Republic in 2008 and the Income share held (as % of total income) in Netherlands in 2012?
Keep it short and to the point. 3.47. What is the difference between the Income share held (as % of total income) in Belgium in 2009 and the Income share held (as % of total income) in Ecuador in 2010?
Make the answer very short. -15.61. What is the difference between the Income share held (as % of total income) of Belgium in 2009 and the Income share held (as % of total income) of Netherlands in 2010?
Your answer should be very brief. 0.12. What is the difference between the Income share held (as % of total income) of Ecuador in 2009 and the Income share held (as % of total income) of Netherlands in 2010?
Provide a short and direct response. 15.62. What is the difference between the Income share held (as % of total income) in Kyrgyz Republic in 2009 and the Income share held (as % of total income) in Netherlands in 2010?
Offer a very short reply. 1.96. What is the difference between the Income share held (as % of total income) of Belgium in 2009 and the Income share held (as % of total income) of Ecuador in 2011?
Your response must be concise. -12.09. What is the difference between the Income share held (as % of total income) in Belgium in 2009 and the Income share held (as % of total income) in Kyrgyz Republic in 2011?
Offer a very short reply. -0.69. What is the difference between the Income share held (as % of total income) of Belgium in 2009 and the Income share held (as % of total income) of Netherlands in 2011?
Offer a terse response. 0.08. What is the difference between the Income share held (as % of total income) in Ecuador in 2009 and the Income share held (as % of total income) in Kyrgyz Republic in 2011?
Provide a succinct answer. 14.81. What is the difference between the Income share held (as % of total income) in Ecuador in 2009 and the Income share held (as % of total income) in Netherlands in 2011?
Give a very brief answer. 15.58. What is the difference between the Income share held (as % of total income) in Kyrgyz Republic in 2009 and the Income share held (as % of total income) in Netherlands in 2011?
Give a very brief answer. 1.92. What is the difference between the Income share held (as % of total income) in Belgium in 2009 and the Income share held (as % of total income) in Ecuador in 2012?
Provide a succinct answer. -12.66. What is the difference between the Income share held (as % of total income) of Belgium in 2009 and the Income share held (as % of total income) of Kyrgyz Republic in 2012?
Keep it short and to the point. -0.4. What is the difference between the Income share held (as % of total income) of Belgium in 2009 and the Income share held (as % of total income) of Netherlands in 2012?
Provide a short and direct response. 0.17. What is the difference between the Income share held (as % of total income) of Ecuador in 2009 and the Income share held (as % of total income) of Kyrgyz Republic in 2012?
Make the answer very short. 15.1. What is the difference between the Income share held (as % of total income) in Ecuador in 2009 and the Income share held (as % of total income) in Netherlands in 2012?
Your answer should be compact. 15.67. What is the difference between the Income share held (as % of total income) of Kyrgyz Republic in 2009 and the Income share held (as % of total income) of Netherlands in 2012?
Provide a succinct answer. 2.01. What is the difference between the Income share held (as % of total income) of Belgium in 2010 and the Income share held (as % of total income) of Ecuador in 2011?
Give a very brief answer. -12.06. What is the difference between the Income share held (as % of total income) in Belgium in 2010 and the Income share held (as % of total income) in Kyrgyz Republic in 2011?
Offer a terse response. -0.66. What is the difference between the Income share held (as % of total income) of Belgium in 2010 and the Income share held (as % of total income) of Netherlands in 2011?
Ensure brevity in your answer.  0.11. What is the difference between the Income share held (as % of total income) in Ecuador in 2010 and the Income share held (as % of total income) in Kyrgyz Republic in 2011?
Keep it short and to the point. 14.92. What is the difference between the Income share held (as % of total income) of Ecuador in 2010 and the Income share held (as % of total income) of Netherlands in 2011?
Ensure brevity in your answer.  15.69. What is the difference between the Income share held (as % of total income) in Kyrgyz Republic in 2010 and the Income share held (as % of total income) in Netherlands in 2011?
Keep it short and to the point. 1.88. What is the difference between the Income share held (as % of total income) in Belgium in 2010 and the Income share held (as % of total income) in Ecuador in 2012?
Your answer should be compact. -12.63. What is the difference between the Income share held (as % of total income) in Belgium in 2010 and the Income share held (as % of total income) in Kyrgyz Republic in 2012?
Make the answer very short. -0.37. What is the difference between the Income share held (as % of total income) of Belgium in 2010 and the Income share held (as % of total income) of Netherlands in 2012?
Give a very brief answer. 0.2. What is the difference between the Income share held (as % of total income) in Ecuador in 2010 and the Income share held (as % of total income) in Kyrgyz Republic in 2012?
Your answer should be very brief. 15.21. What is the difference between the Income share held (as % of total income) of Ecuador in 2010 and the Income share held (as % of total income) of Netherlands in 2012?
Keep it short and to the point. 15.78. What is the difference between the Income share held (as % of total income) of Kyrgyz Republic in 2010 and the Income share held (as % of total income) of Netherlands in 2012?
Keep it short and to the point. 1.97. What is the difference between the Income share held (as % of total income) in Belgium in 2011 and the Income share held (as % of total income) in Ecuador in 2012?
Provide a short and direct response. -12.97. What is the difference between the Income share held (as % of total income) of Belgium in 2011 and the Income share held (as % of total income) of Kyrgyz Republic in 2012?
Provide a succinct answer. -0.71. What is the difference between the Income share held (as % of total income) of Belgium in 2011 and the Income share held (as % of total income) of Netherlands in 2012?
Provide a succinct answer. -0.14. What is the difference between the Income share held (as % of total income) in Ecuador in 2011 and the Income share held (as % of total income) in Kyrgyz Republic in 2012?
Provide a succinct answer. 11.69. What is the difference between the Income share held (as % of total income) in Ecuador in 2011 and the Income share held (as % of total income) in Netherlands in 2012?
Ensure brevity in your answer.  12.26. What is the difference between the Income share held (as % of total income) of Kyrgyz Republic in 2011 and the Income share held (as % of total income) of Netherlands in 2012?
Offer a terse response. 0.86. What is the average Income share held (as % of total income) of Belgium per year?
Make the answer very short. 22.85. What is the average Income share held (as % of total income) in Ecuador per year?
Provide a short and direct response. 39.32. What is the average Income share held (as % of total income) in Kyrgyz Republic per year?
Your answer should be very brief. 25.85. What is the average Income share held (as % of total income) in Netherlands per year?
Your answer should be very brief. 23.35. In the year 2005, what is the difference between the Income share held (as % of total income) of Belgium and Income share held (as % of total income) of Ecuador?
Your answer should be compact. -18.61. In the year 2005, what is the difference between the Income share held (as % of total income) in Belgium and Income share held (as % of total income) in Kyrgyz Republic?
Offer a very short reply. -4.54. In the year 2005, what is the difference between the Income share held (as % of total income) of Belgium and Income share held (as % of total income) of Netherlands?
Keep it short and to the point. 0.43. In the year 2005, what is the difference between the Income share held (as % of total income) in Ecuador and Income share held (as % of total income) in Kyrgyz Republic?
Your response must be concise. 14.07. In the year 2005, what is the difference between the Income share held (as % of total income) of Ecuador and Income share held (as % of total income) of Netherlands?
Make the answer very short. 19.04. In the year 2005, what is the difference between the Income share held (as % of total income) in Kyrgyz Republic and Income share held (as % of total income) in Netherlands?
Make the answer very short. 4.97. In the year 2006, what is the difference between the Income share held (as % of total income) in Belgium and Income share held (as % of total income) in Ecuador?
Provide a succinct answer. -20.01. In the year 2006, what is the difference between the Income share held (as % of total income) of Belgium and Income share held (as % of total income) of Kyrgyz Republic?
Provide a short and direct response. -6.26. In the year 2006, what is the difference between the Income share held (as % of total income) in Belgium and Income share held (as % of total income) in Netherlands?
Offer a very short reply. -2.4. In the year 2006, what is the difference between the Income share held (as % of total income) of Ecuador and Income share held (as % of total income) of Kyrgyz Republic?
Make the answer very short. 13.75. In the year 2006, what is the difference between the Income share held (as % of total income) of Ecuador and Income share held (as % of total income) of Netherlands?
Offer a terse response. 17.61. In the year 2006, what is the difference between the Income share held (as % of total income) of Kyrgyz Republic and Income share held (as % of total income) of Netherlands?
Your answer should be very brief. 3.86. In the year 2007, what is the difference between the Income share held (as % of total income) in Belgium and Income share held (as % of total income) in Ecuador?
Offer a terse response. -19.72. In the year 2007, what is the difference between the Income share held (as % of total income) in Belgium and Income share held (as % of total income) in Kyrgyz Republic?
Provide a succinct answer. -4.26. In the year 2007, what is the difference between the Income share held (as % of total income) of Belgium and Income share held (as % of total income) of Netherlands?
Your answer should be compact. -0.63. In the year 2007, what is the difference between the Income share held (as % of total income) in Ecuador and Income share held (as % of total income) in Kyrgyz Republic?
Your answer should be compact. 15.46. In the year 2007, what is the difference between the Income share held (as % of total income) in Ecuador and Income share held (as % of total income) in Netherlands?
Offer a very short reply. 19.09. In the year 2007, what is the difference between the Income share held (as % of total income) in Kyrgyz Republic and Income share held (as % of total income) in Netherlands?
Make the answer very short. 3.63. In the year 2008, what is the difference between the Income share held (as % of total income) in Belgium and Income share held (as % of total income) in Ecuador?
Offer a terse response. -16.5. In the year 2008, what is the difference between the Income share held (as % of total income) of Belgium and Income share held (as % of total income) of Kyrgyz Republic?
Give a very brief answer. -3.19. In the year 2008, what is the difference between the Income share held (as % of total income) in Belgium and Income share held (as % of total income) in Netherlands?
Provide a short and direct response. -0.96. In the year 2008, what is the difference between the Income share held (as % of total income) in Ecuador and Income share held (as % of total income) in Kyrgyz Republic?
Make the answer very short. 13.31. In the year 2008, what is the difference between the Income share held (as % of total income) of Ecuador and Income share held (as % of total income) of Netherlands?
Keep it short and to the point. 15.54. In the year 2008, what is the difference between the Income share held (as % of total income) in Kyrgyz Republic and Income share held (as % of total income) in Netherlands?
Your answer should be very brief. 2.23. In the year 2009, what is the difference between the Income share held (as % of total income) in Belgium and Income share held (as % of total income) in Ecuador?
Make the answer very short. -15.5. In the year 2009, what is the difference between the Income share held (as % of total income) of Belgium and Income share held (as % of total income) of Kyrgyz Republic?
Keep it short and to the point. -1.84. In the year 2009, what is the difference between the Income share held (as % of total income) of Belgium and Income share held (as % of total income) of Netherlands?
Provide a succinct answer. 0.24. In the year 2009, what is the difference between the Income share held (as % of total income) of Ecuador and Income share held (as % of total income) of Kyrgyz Republic?
Keep it short and to the point. 13.66. In the year 2009, what is the difference between the Income share held (as % of total income) of Ecuador and Income share held (as % of total income) of Netherlands?
Give a very brief answer. 15.74. In the year 2009, what is the difference between the Income share held (as % of total income) of Kyrgyz Republic and Income share held (as % of total income) of Netherlands?
Your response must be concise. 2.08. In the year 2010, what is the difference between the Income share held (as % of total income) of Belgium and Income share held (as % of total income) of Ecuador?
Ensure brevity in your answer.  -15.58. In the year 2010, what is the difference between the Income share held (as % of total income) in Belgium and Income share held (as % of total income) in Kyrgyz Republic?
Provide a short and direct response. -1.77. In the year 2010, what is the difference between the Income share held (as % of total income) in Ecuador and Income share held (as % of total income) in Kyrgyz Republic?
Your answer should be very brief. 13.81. In the year 2010, what is the difference between the Income share held (as % of total income) of Ecuador and Income share held (as % of total income) of Netherlands?
Your answer should be compact. 15.73. In the year 2010, what is the difference between the Income share held (as % of total income) of Kyrgyz Republic and Income share held (as % of total income) of Netherlands?
Give a very brief answer. 1.92. In the year 2011, what is the difference between the Income share held (as % of total income) in Belgium and Income share held (as % of total income) in Ecuador?
Give a very brief answer. -12.4. In the year 2011, what is the difference between the Income share held (as % of total income) in Belgium and Income share held (as % of total income) in Netherlands?
Offer a very short reply. -0.23. In the year 2011, what is the difference between the Income share held (as % of total income) of Ecuador and Income share held (as % of total income) of Netherlands?
Provide a succinct answer. 12.17. In the year 2011, what is the difference between the Income share held (as % of total income) in Kyrgyz Republic and Income share held (as % of total income) in Netherlands?
Your answer should be very brief. 0.77. In the year 2012, what is the difference between the Income share held (as % of total income) of Belgium and Income share held (as % of total income) of Ecuador?
Offer a very short reply. -13.44. In the year 2012, what is the difference between the Income share held (as % of total income) of Belgium and Income share held (as % of total income) of Kyrgyz Republic?
Give a very brief answer. -1.18. In the year 2012, what is the difference between the Income share held (as % of total income) in Belgium and Income share held (as % of total income) in Netherlands?
Give a very brief answer. -0.61. In the year 2012, what is the difference between the Income share held (as % of total income) of Ecuador and Income share held (as % of total income) of Kyrgyz Republic?
Your answer should be compact. 12.26. In the year 2012, what is the difference between the Income share held (as % of total income) of Ecuador and Income share held (as % of total income) of Netherlands?
Offer a very short reply. 12.83. In the year 2012, what is the difference between the Income share held (as % of total income) of Kyrgyz Republic and Income share held (as % of total income) of Netherlands?
Keep it short and to the point. 0.57. What is the ratio of the Income share held (as % of total income) in Belgium in 2005 to that in 2006?
Your answer should be compact. 1.07. What is the ratio of the Income share held (as % of total income) of Ecuador in 2005 to that in 2006?
Your answer should be compact. 1. What is the ratio of the Income share held (as % of total income) in Netherlands in 2005 to that in 2006?
Your answer should be very brief. 0.95. What is the ratio of the Income share held (as % of total income) in Belgium in 2005 to that in 2007?
Your answer should be very brief. 1.02. What is the ratio of the Income share held (as % of total income) in Ecuador in 2005 to that in 2007?
Your answer should be compact. 0.98. What is the ratio of the Income share held (as % of total income) of Kyrgyz Republic in 2005 to that in 2007?
Your response must be concise. 1.02. What is the ratio of the Income share held (as % of total income) of Netherlands in 2005 to that in 2007?
Your answer should be compact. 0.97. What is the ratio of the Income share held (as % of total income) of Belgium in 2005 to that in 2008?
Offer a very short reply. 1.05. What is the ratio of the Income share held (as % of total income) of Ecuador in 2005 to that in 2008?
Keep it short and to the point. 1.08. What is the ratio of the Income share held (as % of total income) in Kyrgyz Republic in 2005 to that in 2008?
Give a very brief answer. 1.1. What is the ratio of the Income share held (as % of total income) of Belgium in 2005 to that in 2009?
Ensure brevity in your answer.  1.05. What is the ratio of the Income share held (as % of total income) in Ecuador in 2005 to that in 2009?
Your response must be concise. 1.11. What is the ratio of the Income share held (as % of total income) in Kyrgyz Republic in 2005 to that in 2009?
Ensure brevity in your answer.  1.16. What is the ratio of the Income share held (as % of total income) in Netherlands in 2005 to that in 2009?
Keep it short and to the point. 1.05. What is the ratio of the Income share held (as % of total income) of Belgium in 2005 to that in 2010?
Your response must be concise. 1.05. What is the ratio of the Income share held (as % of total income) of Ecuador in 2005 to that in 2010?
Make the answer very short. 1.11. What is the ratio of the Income share held (as % of total income) in Kyrgyz Republic in 2005 to that in 2010?
Ensure brevity in your answer.  1.16. What is the ratio of the Income share held (as % of total income) in Netherlands in 2005 to that in 2010?
Offer a very short reply. 1.04. What is the ratio of the Income share held (as % of total income) of Belgium in 2005 to that in 2011?
Provide a succinct answer. 1.07. What is the ratio of the Income share held (as % of total income) in Ecuador in 2005 to that in 2011?
Make the answer very short. 1.22. What is the ratio of the Income share held (as % of total income) in Kyrgyz Republic in 2005 to that in 2011?
Offer a terse response. 1.22. What is the ratio of the Income share held (as % of total income) of Netherlands in 2005 to that in 2011?
Make the answer very short. 1.04. What is the ratio of the Income share held (as % of total income) of Belgium in 2005 to that in 2012?
Keep it short and to the point. 1.09. What is the ratio of the Income share held (as % of total income) of Ecuador in 2005 to that in 2012?
Your answer should be compact. 1.2. What is the ratio of the Income share held (as % of total income) in Kyrgyz Republic in 2005 to that in 2012?
Your answer should be very brief. 1.23. What is the ratio of the Income share held (as % of total income) in Netherlands in 2005 to that in 2012?
Keep it short and to the point. 1.04. What is the ratio of the Income share held (as % of total income) in Belgium in 2006 to that in 2007?
Offer a very short reply. 0.95. What is the ratio of the Income share held (as % of total income) of Ecuador in 2006 to that in 2007?
Your answer should be compact. 0.98. What is the ratio of the Income share held (as % of total income) of Kyrgyz Republic in 2006 to that in 2007?
Your response must be concise. 1.03. What is the ratio of the Income share held (as % of total income) of Netherlands in 2006 to that in 2007?
Give a very brief answer. 1.03. What is the ratio of the Income share held (as % of total income) of Belgium in 2006 to that in 2008?
Offer a terse response. 0.98. What is the ratio of the Income share held (as % of total income) in Ecuador in 2006 to that in 2008?
Make the answer very short. 1.08. What is the ratio of the Income share held (as % of total income) in Kyrgyz Republic in 2006 to that in 2008?
Keep it short and to the point. 1.1. What is the ratio of the Income share held (as % of total income) in Netherlands in 2006 to that in 2008?
Ensure brevity in your answer.  1.04. What is the ratio of the Income share held (as % of total income) in Belgium in 2006 to that in 2009?
Provide a succinct answer. 0.99. What is the ratio of the Income share held (as % of total income) in Ecuador in 2006 to that in 2009?
Offer a very short reply. 1.11. What is the ratio of the Income share held (as % of total income) of Kyrgyz Republic in 2006 to that in 2009?
Offer a very short reply. 1.17. What is the ratio of the Income share held (as % of total income) in Netherlands in 2006 to that in 2009?
Your answer should be very brief. 1.1. What is the ratio of the Income share held (as % of total income) of Belgium in 2006 to that in 2010?
Offer a very short reply. 0.99. What is the ratio of the Income share held (as % of total income) of Ecuador in 2006 to that in 2010?
Make the answer very short. 1.11. What is the ratio of the Income share held (as % of total income) of Kyrgyz Republic in 2006 to that in 2010?
Make the answer very short. 1.17. What is the ratio of the Income share held (as % of total income) in Netherlands in 2006 to that in 2010?
Your response must be concise. 1.1. What is the ratio of the Income share held (as % of total income) in Ecuador in 2006 to that in 2011?
Provide a succinct answer. 1.22. What is the ratio of the Income share held (as % of total income) in Kyrgyz Republic in 2006 to that in 2011?
Your answer should be compact. 1.23. What is the ratio of the Income share held (as % of total income) of Netherlands in 2006 to that in 2011?
Offer a terse response. 1.1. What is the ratio of the Income share held (as % of total income) of Belgium in 2006 to that in 2012?
Offer a terse response. 1.02. What is the ratio of the Income share held (as % of total income) in Ecuador in 2006 to that in 2012?
Offer a terse response. 1.2. What is the ratio of the Income share held (as % of total income) of Kyrgyz Republic in 2006 to that in 2012?
Offer a terse response. 1.24. What is the ratio of the Income share held (as % of total income) in Netherlands in 2006 to that in 2012?
Make the answer very short. 1.1. What is the ratio of the Income share held (as % of total income) of Belgium in 2007 to that in 2008?
Make the answer very short. 1.03. What is the ratio of the Income share held (as % of total income) of Ecuador in 2007 to that in 2008?
Ensure brevity in your answer.  1.1. What is the ratio of the Income share held (as % of total income) in Kyrgyz Republic in 2007 to that in 2008?
Offer a terse response. 1.07. What is the ratio of the Income share held (as % of total income) of Netherlands in 2007 to that in 2008?
Provide a succinct answer. 1.02. What is the ratio of the Income share held (as % of total income) of Belgium in 2007 to that in 2009?
Provide a succinct answer. 1.04. What is the ratio of the Income share held (as % of total income) of Ecuador in 2007 to that in 2009?
Provide a succinct answer. 1.13. What is the ratio of the Income share held (as % of total income) of Kyrgyz Republic in 2007 to that in 2009?
Your answer should be compact. 1.13. What is the ratio of the Income share held (as % of total income) of Netherlands in 2007 to that in 2009?
Your answer should be compact. 1.08. What is the ratio of the Income share held (as % of total income) of Belgium in 2007 to that in 2010?
Make the answer very short. 1.04. What is the ratio of the Income share held (as % of total income) in Ecuador in 2007 to that in 2010?
Your answer should be very brief. 1.13. What is the ratio of the Income share held (as % of total income) in Kyrgyz Republic in 2007 to that in 2010?
Your answer should be very brief. 1.14. What is the ratio of the Income share held (as % of total income) in Netherlands in 2007 to that in 2010?
Give a very brief answer. 1.07. What is the ratio of the Income share held (as % of total income) in Belgium in 2007 to that in 2011?
Give a very brief answer. 1.05. What is the ratio of the Income share held (as % of total income) in Ecuador in 2007 to that in 2011?
Keep it short and to the point. 1.24. What is the ratio of the Income share held (as % of total income) of Kyrgyz Republic in 2007 to that in 2011?
Your response must be concise. 1.19. What is the ratio of the Income share held (as % of total income) in Netherlands in 2007 to that in 2011?
Your response must be concise. 1.07. What is the ratio of the Income share held (as % of total income) of Belgium in 2007 to that in 2012?
Keep it short and to the point. 1.08. What is the ratio of the Income share held (as % of total income) of Ecuador in 2007 to that in 2012?
Make the answer very short. 1.22. What is the ratio of the Income share held (as % of total income) of Kyrgyz Republic in 2007 to that in 2012?
Your answer should be compact. 1.2. What is the ratio of the Income share held (as % of total income) in Netherlands in 2007 to that in 2012?
Give a very brief answer. 1.07. What is the ratio of the Income share held (as % of total income) of Ecuador in 2008 to that in 2009?
Keep it short and to the point. 1.03. What is the ratio of the Income share held (as % of total income) of Kyrgyz Republic in 2008 to that in 2009?
Ensure brevity in your answer.  1.06. What is the ratio of the Income share held (as % of total income) in Netherlands in 2008 to that in 2009?
Give a very brief answer. 1.06. What is the ratio of the Income share held (as % of total income) of Belgium in 2008 to that in 2010?
Ensure brevity in your answer.  1. What is the ratio of the Income share held (as % of total income) of Ecuador in 2008 to that in 2010?
Ensure brevity in your answer.  1.03. What is the ratio of the Income share held (as % of total income) of Kyrgyz Republic in 2008 to that in 2010?
Keep it short and to the point. 1.06. What is the ratio of the Income share held (as % of total income) of Netherlands in 2008 to that in 2010?
Make the answer very short. 1.05. What is the ratio of the Income share held (as % of total income) in Belgium in 2008 to that in 2011?
Make the answer very short. 1.02. What is the ratio of the Income share held (as % of total income) in Ecuador in 2008 to that in 2011?
Ensure brevity in your answer.  1.13. What is the ratio of the Income share held (as % of total income) in Kyrgyz Republic in 2008 to that in 2011?
Make the answer very short. 1.11. What is the ratio of the Income share held (as % of total income) in Netherlands in 2008 to that in 2011?
Provide a succinct answer. 1.05. What is the ratio of the Income share held (as % of total income) in Belgium in 2008 to that in 2012?
Your response must be concise. 1.04. What is the ratio of the Income share held (as % of total income) of Ecuador in 2008 to that in 2012?
Provide a short and direct response. 1.11. What is the ratio of the Income share held (as % of total income) in Kyrgyz Republic in 2008 to that in 2012?
Provide a short and direct response. 1.13. What is the ratio of the Income share held (as % of total income) of Netherlands in 2008 to that in 2012?
Ensure brevity in your answer.  1.05. What is the ratio of the Income share held (as % of total income) of Ecuador in 2009 to that in 2010?
Ensure brevity in your answer.  1. What is the ratio of the Income share held (as % of total income) in Kyrgyz Republic in 2009 to that in 2010?
Offer a very short reply. 1. What is the ratio of the Income share held (as % of total income) in Netherlands in 2009 to that in 2010?
Provide a short and direct response. 0.99. What is the ratio of the Income share held (as % of total income) in Belgium in 2009 to that in 2011?
Provide a succinct answer. 1.01. What is the ratio of the Income share held (as % of total income) of Ecuador in 2009 to that in 2011?
Ensure brevity in your answer.  1.1. What is the ratio of the Income share held (as % of total income) of Kyrgyz Republic in 2009 to that in 2011?
Provide a short and direct response. 1.05. What is the ratio of the Income share held (as % of total income) in Belgium in 2009 to that in 2012?
Your answer should be compact. 1.04. What is the ratio of the Income share held (as % of total income) in Ecuador in 2009 to that in 2012?
Keep it short and to the point. 1.08. What is the ratio of the Income share held (as % of total income) of Kyrgyz Republic in 2009 to that in 2012?
Provide a short and direct response. 1.06. What is the ratio of the Income share held (as % of total income) in Netherlands in 2009 to that in 2012?
Your answer should be compact. 1. What is the ratio of the Income share held (as % of total income) in Belgium in 2010 to that in 2011?
Ensure brevity in your answer.  1.02. What is the ratio of the Income share held (as % of total income) in Ecuador in 2010 to that in 2011?
Offer a terse response. 1.1. What is the ratio of the Income share held (as % of total income) in Kyrgyz Republic in 2010 to that in 2011?
Ensure brevity in your answer.  1.05. What is the ratio of the Income share held (as % of total income) of Netherlands in 2010 to that in 2011?
Give a very brief answer. 1. What is the ratio of the Income share held (as % of total income) in Belgium in 2010 to that in 2012?
Your answer should be very brief. 1.04. What is the ratio of the Income share held (as % of total income) in Ecuador in 2010 to that in 2012?
Provide a short and direct response. 1.08. What is the ratio of the Income share held (as % of total income) in Kyrgyz Republic in 2010 to that in 2012?
Offer a very short reply. 1.06. What is the ratio of the Income share held (as % of total income) in Netherlands in 2010 to that in 2012?
Offer a very short reply. 1. What is the ratio of the Income share held (as % of total income) of Belgium in 2011 to that in 2012?
Ensure brevity in your answer.  1.02. What is the ratio of the Income share held (as % of total income) in Ecuador in 2011 to that in 2012?
Your answer should be compact. 0.98. What is the ratio of the Income share held (as % of total income) of Kyrgyz Republic in 2011 to that in 2012?
Give a very brief answer. 1.01. What is the difference between the highest and the second highest Income share held (as % of total income) of Belgium?
Your response must be concise. 0.37. What is the difference between the highest and the second highest Income share held (as % of total income) of Ecuador?
Your response must be concise. 0.74. What is the difference between the highest and the second highest Income share held (as % of total income) of Kyrgyz Republic?
Provide a short and direct response. 0.19. What is the difference between the highest and the second highest Income share held (as % of total income) of Netherlands?
Provide a succinct answer. 0.61. What is the difference between the highest and the lowest Income share held (as % of total income) in Belgium?
Your response must be concise. 2.02. What is the difference between the highest and the lowest Income share held (as % of total income) in Ecuador?
Your response must be concise. 8.5. What is the difference between the highest and the lowest Income share held (as % of total income) of Kyrgyz Republic?
Provide a succinct answer. 5.57. What is the difference between the highest and the lowest Income share held (as % of total income) of Netherlands?
Provide a succinct answer. 2.35. 